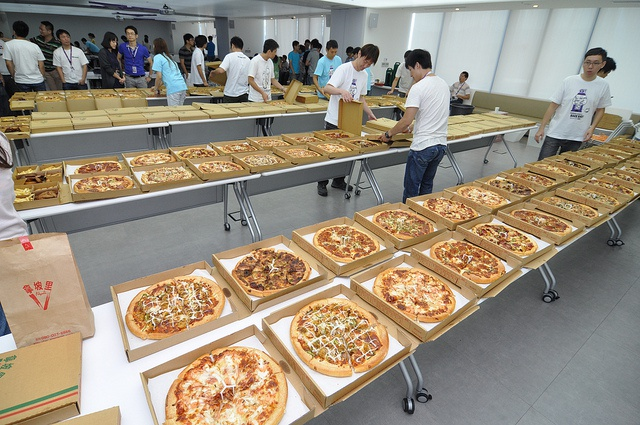Describe the objects in this image and their specific colors. I can see people in black, gray, darkgray, and tan tones, dining table in black, tan, gray, and lightgray tones, pizza in black, tan, gray, and olive tones, pizza in black, tan, and ivory tones, and pizza in black, tan, ivory, and brown tones in this image. 